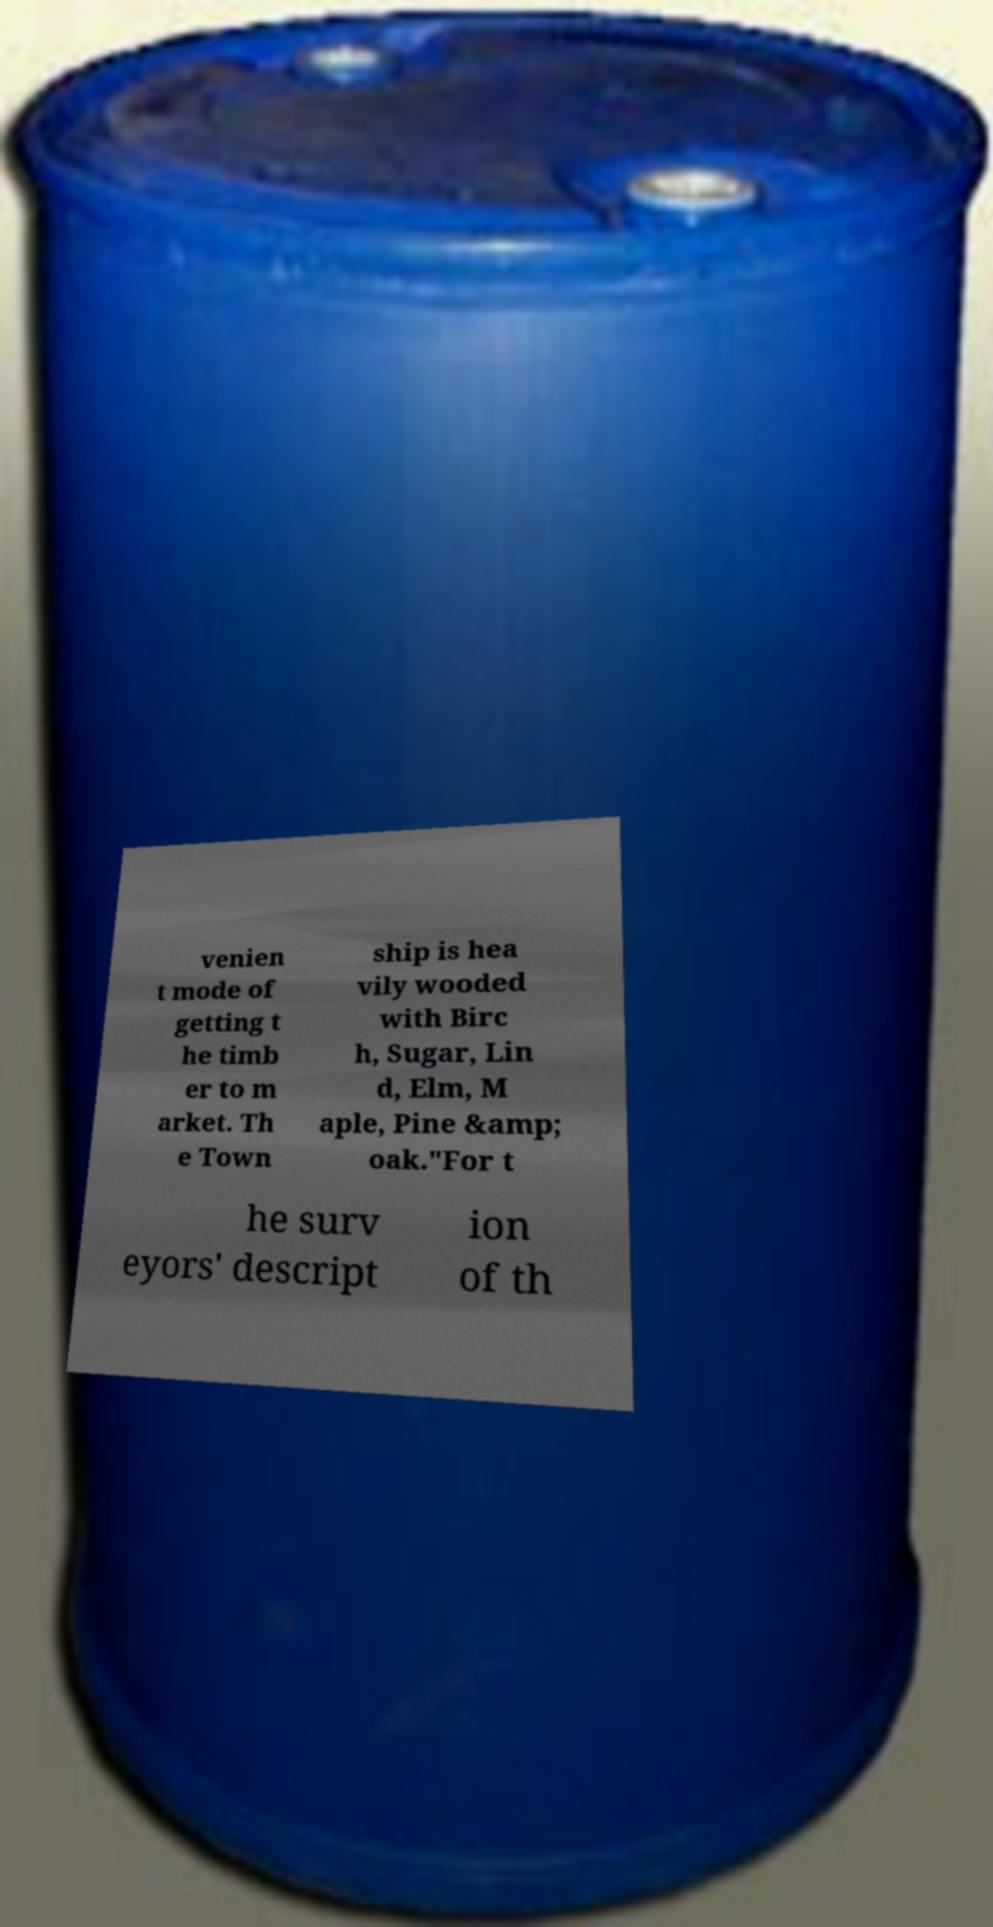What messages or text are displayed in this image? I need them in a readable, typed format. venien t mode of getting t he timb er to m arket. Th e Town ship is hea vily wooded with Birc h, Sugar, Lin d, Elm, M aple, Pine &amp; oak."For t he surv eyors' descript ion of th 